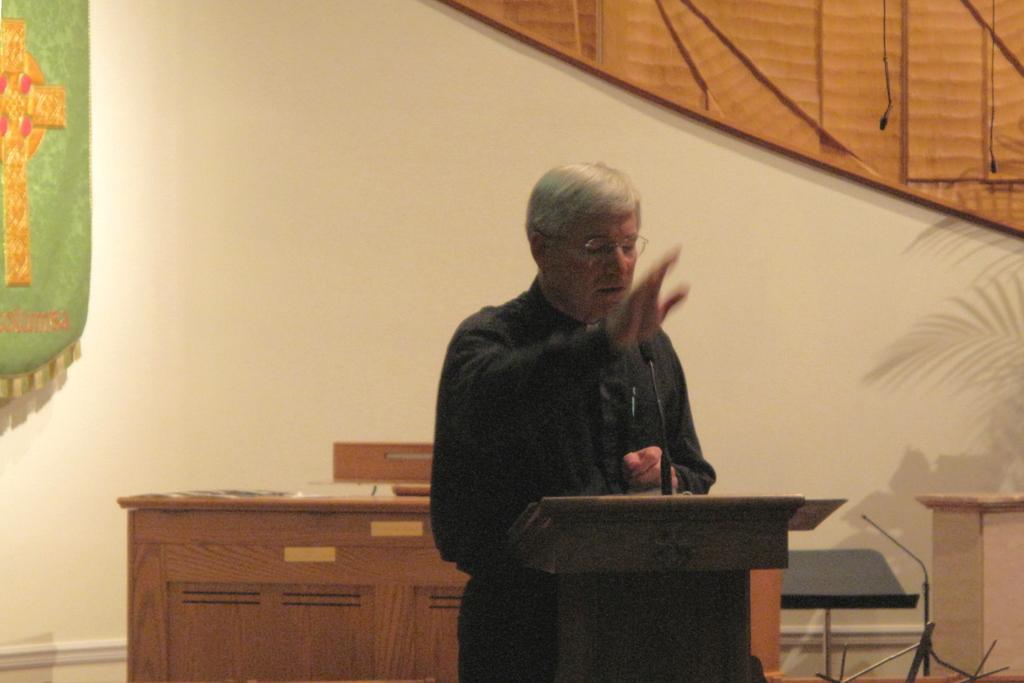How would you summarize this image in a sentence or two? There is a table of brown color in the middle, And there is a man standing and he is raising his hand, In the right side there is a small table of brown color, In the background there is a wall of white color on that wall there is a curtain of yellow color. 